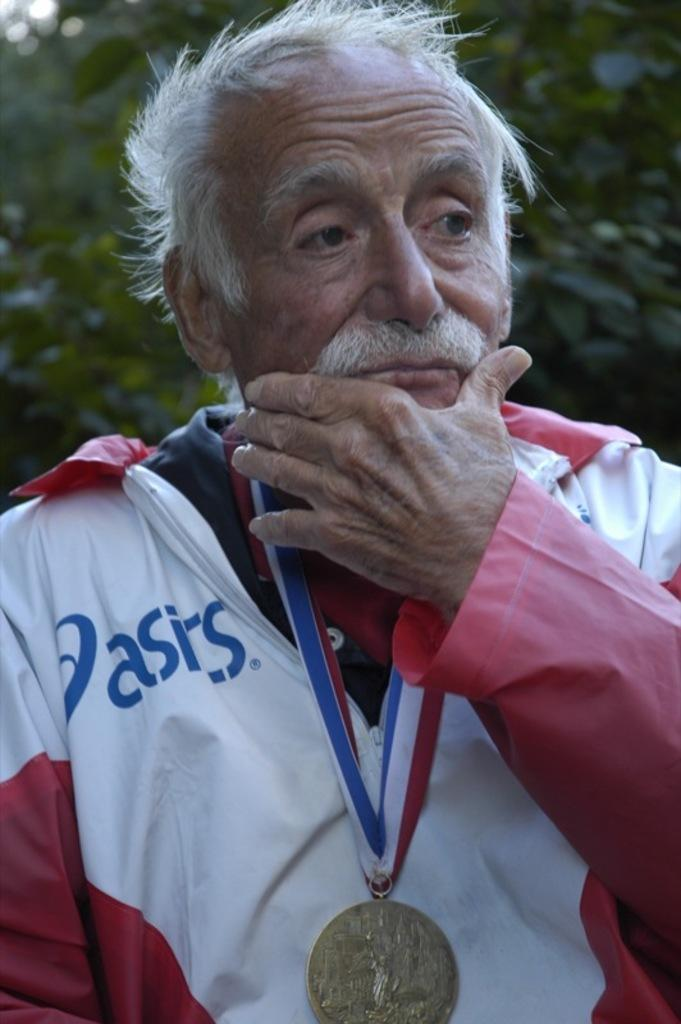<image>
Relay a brief, clear account of the picture shown. A man in an asics brand jacket wears a medal around his neck. 